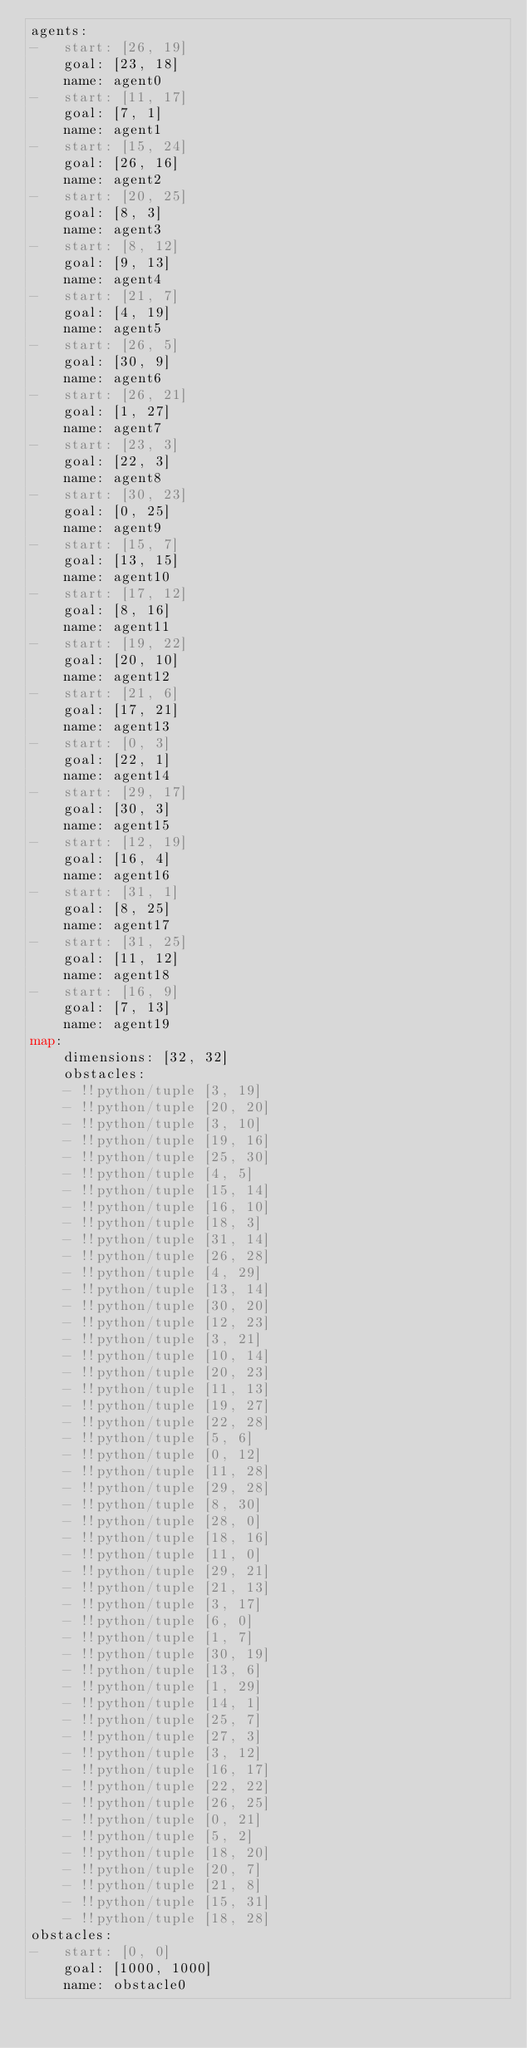<code> <loc_0><loc_0><loc_500><loc_500><_YAML_>agents:
-   start: [26, 19]
    goal: [23, 18]
    name: agent0
-   start: [11, 17]
    goal: [7, 1]
    name: agent1
-   start: [15, 24]
    goal: [26, 16]
    name: agent2
-   start: [20, 25]
    goal: [8, 3]
    name: agent3
-   start: [8, 12]
    goal: [9, 13]
    name: agent4
-   start: [21, 7]
    goal: [4, 19]
    name: agent5
-   start: [26, 5]
    goal: [30, 9]
    name: agent6
-   start: [26, 21]
    goal: [1, 27]
    name: agent7
-   start: [23, 3]
    goal: [22, 3]
    name: agent8
-   start: [30, 23]
    goal: [0, 25]
    name: agent9
-   start: [15, 7]
    goal: [13, 15]
    name: agent10
-   start: [17, 12]
    goal: [8, 16]
    name: agent11
-   start: [19, 22]
    goal: [20, 10]
    name: agent12
-   start: [21, 6]
    goal: [17, 21]
    name: agent13
-   start: [0, 3]
    goal: [22, 1]
    name: agent14
-   start: [29, 17]
    goal: [30, 3]
    name: agent15
-   start: [12, 19]
    goal: [16, 4]
    name: agent16
-   start: [31, 1]
    goal: [8, 25]
    name: agent17
-   start: [31, 25]
    goal: [11, 12]
    name: agent18
-   start: [16, 9]
    goal: [7, 13]
    name: agent19
map:
    dimensions: [32, 32]
    obstacles:
    - !!python/tuple [3, 19]
    - !!python/tuple [20, 20]
    - !!python/tuple [3, 10]
    - !!python/tuple [19, 16]
    - !!python/tuple [25, 30]
    - !!python/tuple [4, 5]
    - !!python/tuple [15, 14]
    - !!python/tuple [16, 10]
    - !!python/tuple [18, 3]
    - !!python/tuple [31, 14]
    - !!python/tuple [26, 28]
    - !!python/tuple [4, 29]
    - !!python/tuple [13, 14]
    - !!python/tuple [30, 20]
    - !!python/tuple [12, 23]
    - !!python/tuple [3, 21]
    - !!python/tuple [10, 14]
    - !!python/tuple [20, 23]
    - !!python/tuple [11, 13]
    - !!python/tuple [19, 27]
    - !!python/tuple [22, 28]
    - !!python/tuple [5, 6]
    - !!python/tuple [0, 12]
    - !!python/tuple [11, 28]
    - !!python/tuple [29, 28]
    - !!python/tuple [8, 30]
    - !!python/tuple [28, 0]
    - !!python/tuple [18, 16]
    - !!python/tuple [11, 0]
    - !!python/tuple [29, 21]
    - !!python/tuple [21, 13]
    - !!python/tuple [3, 17]
    - !!python/tuple [6, 0]
    - !!python/tuple [1, 7]
    - !!python/tuple [30, 19]
    - !!python/tuple [13, 6]
    - !!python/tuple [1, 29]
    - !!python/tuple [14, 1]
    - !!python/tuple [25, 7]
    - !!python/tuple [27, 3]
    - !!python/tuple [3, 12]
    - !!python/tuple [16, 17]
    - !!python/tuple [22, 22]
    - !!python/tuple [26, 25]
    - !!python/tuple [0, 21]
    - !!python/tuple [5, 2]
    - !!python/tuple [18, 20]
    - !!python/tuple [20, 7]
    - !!python/tuple [21, 8]
    - !!python/tuple [15, 31]
    - !!python/tuple [18, 28]
obstacles:
-   start: [0, 0]
    goal: [1000, 1000]
    name: obstacle0
</code> 